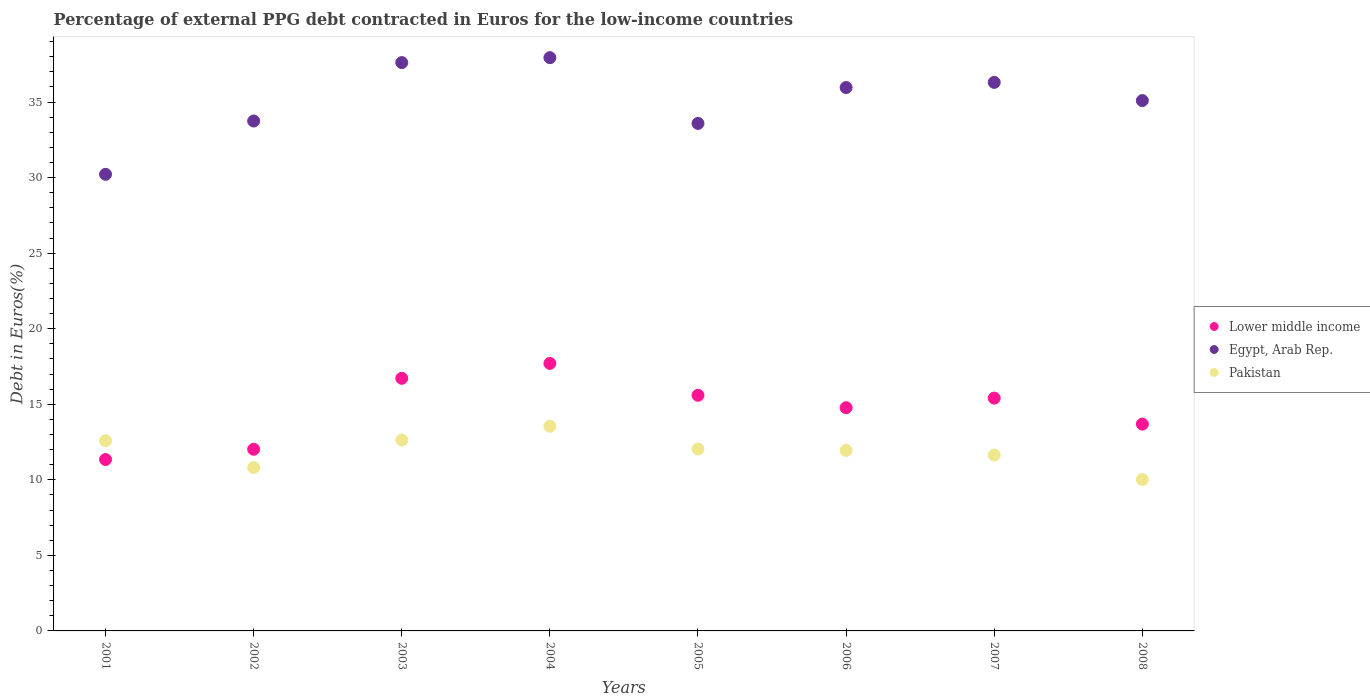How many different coloured dotlines are there?
Your answer should be compact. 3. Is the number of dotlines equal to the number of legend labels?
Provide a succinct answer. Yes. What is the percentage of external PPG debt contracted in Euros in Pakistan in 2005?
Provide a short and direct response. 12.04. Across all years, what is the maximum percentage of external PPG debt contracted in Euros in Lower middle income?
Keep it short and to the point. 17.71. Across all years, what is the minimum percentage of external PPG debt contracted in Euros in Lower middle income?
Your answer should be compact. 11.34. In which year was the percentage of external PPG debt contracted in Euros in Lower middle income maximum?
Make the answer very short. 2004. In which year was the percentage of external PPG debt contracted in Euros in Lower middle income minimum?
Your answer should be compact. 2001. What is the total percentage of external PPG debt contracted in Euros in Lower middle income in the graph?
Ensure brevity in your answer.  117.26. What is the difference between the percentage of external PPG debt contracted in Euros in Egypt, Arab Rep. in 2001 and that in 2005?
Offer a very short reply. -3.37. What is the difference between the percentage of external PPG debt contracted in Euros in Lower middle income in 2007 and the percentage of external PPG debt contracted in Euros in Egypt, Arab Rep. in 2008?
Provide a succinct answer. -19.69. What is the average percentage of external PPG debt contracted in Euros in Lower middle income per year?
Make the answer very short. 14.66. In the year 2005, what is the difference between the percentage of external PPG debt contracted in Euros in Lower middle income and percentage of external PPG debt contracted in Euros in Pakistan?
Your answer should be very brief. 3.55. What is the ratio of the percentage of external PPG debt contracted in Euros in Lower middle income in 2002 to that in 2003?
Your answer should be compact. 0.72. Is the difference between the percentage of external PPG debt contracted in Euros in Lower middle income in 2002 and 2008 greater than the difference between the percentage of external PPG debt contracted in Euros in Pakistan in 2002 and 2008?
Provide a succinct answer. No. What is the difference between the highest and the second highest percentage of external PPG debt contracted in Euros in Pakistan?
Provide a short and direct response. 0.91. What is the difference between the highest and the lowest percentage of external PPG debt contracted in Euros in Egypt, Arab Rep.?
Offer a very short reply. 7.72. In how many years, is the percentage of external PPG debt contracted in Euros in Pakistan greater than the average percentage of external PPG debt contracted in Euros in Pakistan taken over all years?
Keep it short and to the point. 5. Is the sum of the percentage of external PPG debt contracted in Euros in Lower middle income in 2001 and 2004 greater than the maximum percentage of external PPG debt contracted in Euros in Egypt, Arab Rep. across all years?
Give a very brief answer. No. Is it the case that in every year, the sum of the percentage of external PPG debt contracted in Euros in Lower middle income and percentage of external PPG debt contracted in Euros in Egypt, Arab Rep.  is greater than the percentage of external PPG debt contracted in Euros in Pakistan?
Keep it short and to the point. Yes. How many years are there in the graph?
Offer a very short reply. 8. Does the graph contain grids?
Your answer should be very brief. No. What is the title of the graph?
Your answer should be very brief. Percentage of external PPG debt contracted in Euros for the low-income countries. What is the label or title of the X-axis?
Provide a succinct answer. Years. What is the label or title of the Y-axis?
Your answer should be very brief. Debt in Euros(%). What is the Debt in Euros(%) of Lower middle income in 2001?
Your response must be concise. 11.34. What is the Debt in Euros(%) of Egypt, Arab Rep. in 2001?
Provide a short and direct response. 30.22. What is the Debt in Euros(%) in Pakistan in 2001?
Offer a terse response. 12.59. What is the Debt in Euros(%) in Lower middle income in 2002?
Give a very brief answer. 12.02. What is the Debt in Euros(%) in Egypt, Arab Rep. in 2002?
Provide a succinct answer. 33.75. What is the Debt in Euros(%) in Pakistan in 2002?
Provide a succinct answer. 10.81. What is the Debt in Euros(%) of Lower middle income in 2003?
Offer a very short reply. 16.72. What is the Debt in Euros(%) in Egypt, Arab Rep. in 2003?
Give a very brief answer. 37.61. What is the Debt in Euros(%) in Pakistan in 2003?
Make the answer very short. 12.63. What is the Debt in Euros(%) in Lower middle income in 2004?
Your answer should be very brief. 17.71. What is the Debt in Euros(%) in Egypt, Arab Rep. in 2004?
Provide a succinct answer. 37.94. What is the Debt in Euros(%) of Pakistan in 2004?
Make the answer very short. 13.54. What is the Debt in Euros(%) of Lower middle income in 2005?
Your answer should be compact. 15.6. What is the Debt in Euros(%) in Egypt, Arab Rep. in 2005?
Provide a succinct answer. 33.59. What is the Debt in Euros(%) in Pakistan in 2005?
Offer a terse response. 12.04. What is the Debt in Euros(%) in Lower middle income in 2006?
Offer a terse response. 14.77. What is the Debt in Euros(%) of Egypt, Arab Rep. in 2006?
Offer a very short reply. 35.96. What is the Debt in Euros(%) in Pakistan in 2006?
Provide a short and direct response. 11.95. What is the Debt in Euros(%) of Lower middle income in 2007?
Offer a very short reply. 15.41. What is the Debt in Euros(%) in Egypt, Arab Rep. in 2007?
Your answer should be very brief. 36.3. What is the Debt in Euros(%) of Pakistan in 2007?
Make the answer very short. 11.64. What is the Debt in Euros(%) in Lower middle income in 2008?
Give a very brief answer. 13.69. What is the Debt in Euros(%) in Egypt, Arab Rep. in 2008?
Make the answer very short. 35.1. What is the Debt in Euros(%) of Pakistan in 2008?
Provide a short and direct response. 10.02. Across all years, what is the maximum Debt in Euros(%) in Lower middle income?
Your answer should be compact. 17.71. Across all years, what is the maximum Debt in Euros(%) of Egypt, Arab Rep.?
Your response must be concise. 37.94. Across all years, what is the maximum Debt in Euros(%) of Pakistan?
Provide a succinct answer. 13.54. Across all years, what is the minimum Debt in Euros(%) of Lower middle income?
Ensure brevity in your answer.  11.34. Across all years, what is the minimum Debt in Euros(%) of Egypt, Arab Rep.?
Make the answer very short. 30.22. Across all years, what is the minimum Debt in Euros(%) of Pakistan?
Your response must be concise. 10.02. What is the total Debt in Euros(%) of Lower middle income in the graph?
Give a very brief answer. 117.26. What is the total Debt in Euros(%) in Egypt, Arab Rep. in the graph?
Provide a short and direct response. 280.47. What is the total Debt in Euros(%) of Pakistan in the graph?
Ensure brevity in your answer.  95.23. What is the difference between the Debt in Euros(%) in Lower middle income in 2001 and that in 2002?
Offer a very short reply. -0.68. What is the difference between the Debt in Euros(%) in Egypt, Arab Rep. in 2001 and that in 2002?
Offer a terse response. -3.53. What is the difference between the Debt in Euros(%) of Pakistan in 2001 and that in 2002?
Ensure brevity in your answer.  1.77. What is the difference between the Debt in Euros(%) of Lower middle income in 2001 and that in 2003?
Provide a short and direct response. -5.38. What is the difference between the Debt in Euros(%) in Egypt, Arab Rep. in 2001 and that in 2003?
Provide a short and direct response. -7.39. What is the difference between the Debt in Euros(%) of Pakistan in 2001 and that in 2003?
Keep it short and to the point. -0.05. What is the difference between the Debt in Euros(%) in Lower middle income in 2001 and that in 2004?
Keep it short and to the point. -6.36. What is the difference between the Debt in Euros(%) of Egypt, Arab Rep. in 2001 and that in 2004?
Provide a succinct answer. -7.72. What is the difference between the Debt in Euros(%) in Pakistan in 2001 and that in 2004?
Offer a terse response. -0.96. What is the difference between the Debt in Euros(%) of Lower middle income in 2001 and that in 2005?
Give a very brief answer. -4.25. What is the difference between the Debt in Euros(%) in Egypt, Arab Rep. in 2001 and that in 2005?
Offer a very short reply. -3.37. What is the difference between the Debt in Euros(%) of Pakistan in 2001 and that in 2005?
Your answer should be very brief. 0.54. What is the difference between the Debt in Euros(%) of Lower middle income in 2001 and that in 2006?
Offer a terse response. -3.43. What is the difference between the Debt in Euros(%) in Egypt, Arab Rep. in 2001 and that in 2006?
Make the answer very short. -5.74. What is the difference between the Debt in Euros(%) in Pakistan in 2001 and that in 2006?
Keep it short and to the point. 0.64. What is the difference between the Debt in Euros(%) of Lower middle income in 2001 and that in 2007?
Your answer should be very brief. -4.06. What is the difference between the Debt in Euros(%) in Egypt, Arab Rep. in 2001 and that in 2007?
Offer a very short reply. -6.08. What is the difference between the Debt in Euros(%) in Pakistan in 2001 and that in 2007?
Offer a very short reply. 0.95. What is the difference between the Debt in Euros(%) in Lower middle income in 2001 and that in 2008?
Your response must be concise. -2.34. What is the difference between the Debt in Euros(%) in Egypt, Arab Rep. in 2001 and that in 2008?
Give a very brief answer. -4.88. What is the difference between the Debt in Euros(%) of Pakistan in 2001 and that in 2008?
Make the answer very short. 2.57. What is the difference between the Debt in Euros(%) of Lower middle income in 2002 and that in 2003?
Provide a short and direct response. -4.7. What is the difference between the Debt in Euros(%) of Egypt, Arab Rep. in 2002 and that in 2003?
Provide a succinct answer. -3.87. What is the difference between the Debt in Euros(%) in Pakistan in 2002 and that in 2003?
Offer a very short reply. -1.82. What is the difference between the Debt in Euros(%) of Lower middle income in 2002 and that in 2004?
Your answer should be compact. -5.68. What is the difference between the Debt in Euros(%) in Egypt, Arab Rep. in 2002 and that in 2004?
Provide a succinct answer. -4.19. What is the difference between the Debt in Euros(%) in Pakistan in 2002 and that in 2004?
Offer a very short reply. -2.73. What is the difference between the Debt in Euros(%) of Lower middle income in 2002 and that in 2005?
Give a very brief answer. -3.57. What is the difference between the Debt in Euros(%) of Egypt, Arab Rep. in 2002 and that in 2005?
Ensure brevity in your answer.  0.16. What is the difference between the Debt in Euros(%) in Pakistan in 2002 and that in 2005?
Give a very brief answer. -1.23. What is the difference between the Debt in Euros(%) of Lower middle income in 2002 and that in 2006?
Your response must be concise. -2.75. What is the difference between the Debt in Euros(%) in Egypt, Arab Rep. in 2002 and that in 2006?
Keep it short and to the point. -2.22. What is the difference between the Debt in Euros(%) in Pakistan in 2002 and that in 2006?
Your answer should be compact. -1.14. What is the difference between the Debt in Euros(%) of Lower middle income in 2002 and that in 2007?
Provide a short and direct response. -3.39. What is the difference between the Debt in Euros(%) in Egypt, Arab Rep. in 2002 and that in 2007?
Give a very brief answer. -2.56. What is the difference between the Debt in Euros(%) of Pakistan in 2002 and that in 2007?
Ensure brevity in your answer.  -0.83. What is the difference between the Debt in Euros(%) in Lower middle income in 2002 and that in 2008?
Your answer should be very brief. -1.66. What is the difference between the Debt in Euros(%) of Egypt, Arab Rep. in 2002 and that in 2008?
Provide a short and direct response. -1.35. What is the difference between the Debt in Euros(%) in Pakistan in 2002 and that in 2008?
Give a very brief answer. 0.79. What is the difference between the Debt in Euros(%) of Lower middle income in 2003 and that in 2004?
Give a very brief answer. -0.99. What is the difference between the Debt in Euros(%) in Egypt, Arab Rep. in 2003 and that in 2004?
Make the answer very short. -0.33. What is the difference between the Debt in Euros(%) of Pakistan in 2003 and that in 2004?
Your answer should be compact. -0.91. What is the difference between the Debt in Euros(%) in Lower middle income in 2003 and that in 2005?
Your answer should be very brief. 1.12. What is the difference between the Debt in Euros(%) of Egypt, Arab Rep. in 2003 and that in 2005?
Ensure brevity in your answer.  4.02. What is the difference between the Debt in Euros(%) in Pakistan in 2003 and that in 2005?
Ensure brevity in your answer.  0.59. What is the difference between the Debt in Euros(%) in Lower middle income in 2003 and that in 2006?
Provide a succinct answer. 1.95. What is the difference between the Debt in Euros(%) in Egypt, Arab Rep. in 2003 and that in 2006?
Offer a terse response. 1.65. What is the difference between the Debt in Euros(%) of Pakistan in 2003 and that in 2006?
Make the answer very short. 0.69. What is the difference between the Debt in Euros(%) in Lower middle income in 2003 and that in 2007?
Your answer should be compact. 1.31. What is the difference between the Debt in Euros(%) in Egypt, Arab Rep. in 2003 and that in 2007?
Ensure brevity in your answer.  1.31. What is the difference between the Debt in Euros(%) of Pakistan in 2003 and that in 2007?
Provide a short and direct response. 1. What is the difference between the Debt in Euros(%) of Lower middle income in 2003 and that in 2008?
Provide a short and direct response. 3.03. What is the difference between the Debt in Euros(%) of Egypt, Arab Rep. in 2003 and that in 2008?
Keep it short and to the point. 2.51. What is the difference between the Debt in Euros(%) in Pakistan in 2003 and that in 2008?
Your answer should be compact. 2.61. What is the difference between the Debt in Euros(%) in Lower middle income in 2004 and that in 2005?
Your response must be concise. 2.11. What is the difference between the Debt in Euros(%) in Egypt, Arab Rep. in 2004 and that in 2005?
Provide a short and direct response. 4.35. What is the difference between the Debt in Euros(%) in Pakistan in 2004 and that in 2005?
Your answer should be compact. 1.5. What is the difference between the Debt in Euros(%) in Lower middle income in 2004 and that in 2006?
Offer a terse response. 2.93. What is the difference between the Debt in Euros(%) in Egypt, Arab Rep. in 2004 and that in 2006?
Keep it short and to the point. 1.98. What is the difference between the Debt in Euros(%) in Pakistan in 2004 and that in 2006?
Your answer should be very brief. 1.6. What is the difference between the Debt in Euros(%) of Lower middle income in 2004 and that in 2007?
Offer a terse response. 2.3. What is the difference between the Debt in Euros(%) of Egypt, Arab Rep. in 2004 and that in 2007?
Ensure brevity in your answer.  1.64. What is the difference between the Debt in Euros(%) in Pakistan in 2004 and that in 2007?
Give a very brief answer. 1.91. What is the difference between the Debt in Euros(%) of Lower middle income in 2004 and that in 2008?
Your response must be concise. 4.02. What is the difference between the Debt in Euros(%) in Egypt, Arab Rep. in 2004 and that in 2008?
Keep it short and to the point. 2.84. What is the difference between the Debt in Euros(%) of Pakistan in 2004 and that in 2008?
Ensure brevity in your answer.  3.52. What is the difference between the Debt in Euros(%) of Lower middle income in 2005 and that in 2006?
Your answer should be compact. 0.82. What is the difference between the Debt in Euros(%) of Egypt, Arab Rep. in 2005 and that in 2006?
Offer a terse response. -2.37. What is the difference between the Debt in Euros(%) in Pakistan in 2005 and that in 2006?
Ensure brevity in your answer.  0.1. What is the difference between the Debt in Euros(%) in Lower middle income in 2005 and that in 2007?
Make the answer very short. 0.19. What is the difference between the Debt in Euros(%) of Egypt, Arab Rep. in 2005 and that in 2007?
Your response must be concise. -2.71. What is the difference between the Debt in Euros(%) in Pakistan in 2005 and that in 2007?
Ensure brevity in your answer.  0.41. What is the difference between the Debt in Euros(%) in Lower middle income in 2005 and that in 2008?
Provide a short and direct response. 1.91. What is the difference between the Debt in Euros(%) in Egypt, Arab Rep. in 2005 and that in 2008?
Provide a succinct answer. -1.51. What is the difference between the Debt in Euros(%) of Pakistan in 2005 and that in 2008?
Your response must be concise. 2.02. What is the difference between the Debt in Euros(%) of Lower middle income in 2006 and that in 2007?
Your response must be concise. -0.64. What is the difference between the Debt in Euros(%) in Egypt, Arab Rep. in 2006 and that in 2007?
Offer a very short reply. -0.34. What is the difference between the Debt in Euros(%) in Pakistan in 2006 and that in 2007?
Make the answer very short. 0.31. What is the difference between the Debt in Euros(%) in Lower middle income in 2006 and that in 2008?
Give a very brief answer. 1.09. What is the difference between the Debt in Euros(%) of Egypt, Arab Rep. in 2006 and that in 2008?
Your answer should be very brief. 0.86. What is the difference between the Debt in Euros(%) in Pakistan in 2006 and that in 2008?
Provide a short and direct response. 1.93. What is the difference between the Debt in Euros(%) in Lower middle income in 2007 and that in 2008?
Your answer should be very brief. 1.72. What is the difference between the Debt in Euros(%) in Egypt, Arab Rep. in 2007 and that in 2008?
Keep it short and to the point. 1.2. What is the difference between the Debt in Euros(%) of Pakistan in 2007 and that in 2008?
Your answer should be very brief. 1.62. What is the difference between the Debt in Euros(%) of Lower middle income in 2001 and the Debt in Euros(%) of Egypt, Arab Rep. in 2002?
Keep it short and to the point. -22.4. What is the difference between the Debt in Euros(%) of Lower middle income in 2001 and the Debt in Euros(%) of Pakistan in 2002?
Make the answer very short. 0.53. What is the difference between the Debt in Euros(%) in Egypt, Arab Rep. in 2001 and the Debt in Euros(%) in Pakistan in 2002?
Offer a terse response. 19.41. What is the difference between the Debt in Euros(%) in Lower middle income in 2001 and the Debt in Euros(%) in Egypt, Arab Rep. in 2003?
Ensure brevity in your answer.  -26.27. What is the difference between the Debt in Euros(%) of Lower middle income in 2001 and the Debt in Euros(%) of Pakistan in 2003?
Give a very brief answer. -1.29. What is the difference between the Debt in Euros(%) in Egypt, Arab Rep. in 2001 and the Debt in Euros(%) in Pakistan in 2003?
Your response must be concise. 17.59. What is the difference between the Debt in Euros(%) of Lower middle income in 2001 and the Debt in Euros(%) of Egypt, Arab Rep. in 2004?
Ensure brevity in your answer.  -26.6. What is the difference between the Debt in Euros(%) of Lower middle income in 2001 and the Debt in Euros(%) of Pakistan in 2004?
Give a very brief answer. -2.2. What is the difference between the Debt in Euros(%) of Egypt, Arab Rep. in 2001 and the Debt in Euros(%) of Pakistan in 2004?
Make the answer very short. 16.68. What is the difference between the Debt in Euros(%) of Lower middle income in 2001 and the Debt in Euros(%) of Egypt, Arab Rep. in 2005?
Your answer should be compact. -22.25. What is the difference between the Debt in Euros(%) of Lower middle income in 2001 and the Debt in Euros(%) of Pakistan in 2005?
Provide a succinct answer. -0.7. What is the difference between the Debt in Euros(%) of Egypt, Arab Rep. in 2001 and the Debt in Euros(%) of Pakistan in 2005?
Keep it short and to the point. 18.18. What is the difference between the Debt in Euros(%) in Lower middle income in 2001 and the Debt in Euros(%) in Egypt, Arab Rep. in 2006?
Keep it short and to the point. -24.62. What is the difference between the Debt in Euros(%) of Lower middle income in 2001 and the Debt in Euros(%) of Pakistan in 2006?
Your answer should be compact. -0.6. What is the difference between the Debt in Euros(%) of Egypt, Arab Rep. in 2001 and the Debt in Euros(%) of Pakistan in 2006?
Make the answer very short. 18.27. What is the difference between the Debt in Euros(%) of Lower middle income in 2001 and the Debt in Euros(%) of Egypt, Arab Rep. in 2007?
Provide a short and direct response. -24.96. What is the difference between the Debt in Euros(%) in Lower middle income in 2001 and the Debt in Euros(%) in Pakistan in 2007?
Make the answer very short. -0.3. What is the difference between the Debt in Euros(%) of Egypt, Arab Rep. in 2001 and the Debt in Euros(%) of Pakistan in 2007?
Provide a short and direct response. 18.58. What is the difference between the Debt in Euros(%) of Lower middle income in 2001 and the Debt in Euros(%) of Egypt, Arab Rep. in 2008?
Provide a succinct answer. -23.76. What is the difference between the Debt in Euros(%) in Lower middle income in 2001 and the Debt in Euros(%) in Pakistan in 2008?
Offer a terse response. 1.32. What is the difference between the Debt in Euros(%) of Egypt, Arab Rep. in 2001 and the Debt in Euros(%) of Pakistan in 2008?
Give a very brief answer. 20.2. What is the difference between the Debt in Euros(%) of Lower middle income in 2002 and the Debt in Euros(%) of Egypt, Arab Rep. in 2003?
Offer a terse response. -25.59. What is the difference between the Debt in Euros(%) of Lower middle income in 2002 and the Debt in Euros(%) of Pakistan in 2003?
Provide a succinct answer. -0.61. What is the difference between the Debt in Euros(%) in Egypt, Arab Rep. in 2002 and the Debt in Euros(%) in Pakistan in 2003?
Offer a very short reply. 21.11. What is the difference between the Debt in Euros(%) of Lower middle income in 2002 and the Debt in Euros(%) of Egypt, Arab Rep. in 2004?
Give a very brief answer. -25.92. What is the difference between the Debt in Euros(%) in Lower middle income in 2002 and the Debt in Euros(%) in Pakistan in 2004?
Offer a terse response. -1.52. What is the difference between the Debt in Euros(%) in Egypt, Arab Rep. in 2002 and the Debt in Euros(%) in Pakistan in 2004?
Your answer should be compact. 20.2. What is the difference between the Debt in Euros(%) in Lower middle income in 2002 and the Debt in Euros(%) in Egypt, Arab Rep. in 2005?
Ensure brevity in your answer.  -21.57. What is the difference between the Debt in Euros(%) of Lower middle income in 2002 and the Debt in Euros(%) of Pakistan in 2005?
Offer a terse response. -0.02. What is the difference between the Debt in Euros(%) in Egypt, Arab Rep. in 2002 and the Debt in Euros(%) in Pakistan in 2005?
Offer a very short reply. 21.7. What is the difference between the Debt in Euros(%) in Lower middle income in 2002 and the Debt in Euros(%) in Egypt, Arab Rep. in 2006?
Ensure brevity in your answer.  -23.94. What is the difference between the Debt in Euros(%) in Lower middle income in 2002 and the Debt in Euros(%) in Pakistan in 2006?
Keep it short and to the point. 0.08. What is the difference between the Debt in Euros(%) in Egypt, Arab Rep. in 2002 and the Debt in Euros(%) in Pakistan in 2006?
Offer a very short reply. 21.8. What is the difference between the Debt in Euros(%) in Lower middle income in 2002 and the Debt in Euros(%) in Egypt, Arab Rep. in 2007?
Keep it short and to the point. -24.28. What is the difference between the Debt in Euros(%) of Lower middle income in 2002 and the Debt in Euros(%) of Pakistan in 2007?
Offer a very short reply. 0.38. What is the difference between the Debt in Euros(%) of Egypt, Arab Rep. in 2002 and the Debt in Euros(%) of Pakistan in 2007?
Keep it short and to the point. 22.11. What is the difference between the Debt in Euros(%) in Lower middle income in 2002 and the Debt in Euros(%) in Egypt, Arab Rep. in 2008?
Make the answer very short. -23.08. What is the difference between the Debt in Euros(%) in Lower middle income in 2002 and the Debt in Euros(%) in Pakistan in 2008?
Ensure brevity in your answer.  2. What is the difference between the Debt in Euros(%) of Egypt, Arab Rep. in 2002 and the Debt in Euros(%) of Pakistan in 2008?
Offer a terse response. 23.73. What is the difference between the Debt in Euros(%) in Lower middle income in 2003 and the Debt in Euros(%) in Egypt, Arab Rep. in 2004?
Your response must be concise. -21.22. What is the difference between the Debt in Euros(%) in Lower middle income in 2003 and the Debt in Euros(%) in Pakistan in 2004?
Provide a succinct answer. 3.17. What is the difference between the Debt in Euros(%) in Egypt, Arab Rep. in 2003 and the Debt in Euros(%) in Pakistan in 2004?
Give a very brief answer. 24.07. What is the difference between the Debt in Euros(%) of Lower middle income in 2003 and the Debt in Euros(%) of Egypt, Arab Rep. in 2005?
Your answer should be compact. -16.87. What is the difference between the Debt in Euros(%) in Lower middle income in 2003 and the Debt in Euros(%) in Pakistan in 2005?
Provide a succinct answer. 4.68. What is the difference between the Debt in Euros(%) of Egypt, Arab Rep. in 2003 and the Debt in Euros(%) of Pakistan in 2005?
Make the answer very short. 25.57. What is the difference between the Debt in Euros(%) of Lower middle income in 2003 and the Debt in Euros(%) of Egypt, Arab Rep. in 2006?
Ensure brevity in your answer.  -19.24. What is the difference between the Debt in Euros(%) in Lower middle income in 2003 and the Debt in Euros(%) in Pakistan in 2006?
Your response must be concise. 4.77. What is the difference between the Debt in Euros(%) of Egypt, Arab Rep. in 2003 and the Debt in Euros(%) of Pakistan in 2006?
Give a very brief answer. 25.67. What is the difference between the Debt in Euros(%) in Lower middle income in 2003 and the Debt in Euros(%) in Egypt, Arab Rep. in 2007?
Keep it short and to the point. -19.58. What is the difference between the Debt in Euros(%) in Lower middle income in 2003 and the Debt in Euros(%) in Pakistan in 2007?
Your answer should be very brief. 5.08. What is the difference between the Debt in Euros(%) of Egypt, Arab Rep. in 2003 and the Debt in Euros(%) of Pakistan in 2007?
Offer a very short reply. 25.97. What is the difference between the Debt in Euros(%) in Lower middle income in 2003 and the Debt in Euros(%) in Egypt, Arab Rep. in 2008?
Offer a terse response. -18.38. What is the difference between the Debt in Euros(%) of Lower middle income in 2003 and the Debt in Euros(%) of Pakistan in 2008?
Give a very brief answer. 6.7. What is the difference between the Debt in Euros(%) in Egypt, Arab Rep. in 2003 and the Debt in Euros(%) in Pakistan in 2008?
Your answer should be very brief. 27.59. What is the difference between the Debt in Euros(%) in Lower middle income in 2004 and the Debt in Euros(%) in Egypt, Arab Rep. in 2005?
Offer a very short reply. -15.88. What is the difference between the Debt in Euros(%) in Lower middle income in 2004 and the Debt in Euros(%) in Pakistan in 2005?
Your answer should be compact. 5.66. What is the difference between the Debt in Euros(%) in Egypt, Arab Rep. in 2004 and the Debt in Euros(%) in Pakistan in 2005?
Offer a very short reply. 25.9. What is the difference between the Debt in Euros(%) of Lower middle income in 2004 and the Debt in Euros(%) of Egypt, Arab Rep. in 2006?
Your answer should be very brief. -18.26. What is the difference between the Debt in Euros(%) in Lower middle income in 2004 and the Debt in Euros(%) in Pakistan in 2006?
Keep it short and to the point. 5.76. What is the difference between the Debt in Euros(%) of Egypt, Arab Rep. in 2004 and the Debt in Euros(%) of Pakistan in 2006?
Offer a very short reply. 25.99. What is the difference between the Debt in Euros(%) of Lower middle income in 2004 and the Debt in Euros(%) of Egypt, Arab Rep. in 2007?
Your answer should be very brief. -18.6. What is the difference between the Debt in Euros(%) in Lower middle income in 2004 and the Debt in Euros(%) in Pakistan in 2007?
Offer a terse response. 6.07. What is the difference between the Debt in Euros(%) in Egypt, Arab Rep. in 2004 and the Debt in Euros(%) in Pakistan in 2007?
Make the answer very short. 26.3. What is the difference between the Debt in Euros(%) of Lower middle income in 2004 and the Debt in Euros(%) of Egypt, Arab Rep. in 2008?
Give a very brief answer. -17.39. What is the difference between the Debt in Euros(%) in Lower middle income in 2004 and the Debt in Euros(%) in Pakistan in 2008?
Give a very brief answer. 7.69. What is the difference between the Debt in Euros(%) in Egypt, Arab Rep. in 2004 and the Debt in Euros(%) in Pakistan in 2008?
Give a very brief answer. 27.92. What is the difference between the Debt in Euros(%) in Lower middle income in 2005 and the Debt in Euros(%) in Egypt, Arab Rep. in 2006?
Keep it short and to the point. -20.37. What is the difference between the Debt in Euros(%) in Lower middle income in 2005 and the Debt in Euros(%) in Pakistan in 2006?
Keep it short and to the point. 3.65. What is the difference between the Debt in Euros(%) in Egypt, Arab Rep. in 2005 and the Debt in Euros(%) in Pakistan in 2006?
Offer a very short reply. 21.64. What is the difference between the Debt in Euros(%) in Lower middle income in 2005 and the Debt in Euros(%) in Egypt, Arab Rep. in 2007?
Your answer should be very brief. -20.71. What is the difference between the Debt in Euros(%) of Lower middle income in 2005 and the Debt in Euros(%) of Pakistan in 2007?
Your response must be concise. 3.96. What is the difference between the Debt in Euros(%) in Egypt, Arab Rep. in 2005 and the Debt in Euros(%) in Pakistan in 2007?
Make the answer very short. 21.95. What is the difference between the Debt in Euros(%) of Lower middle income in 2005 and the Debt in Euros(%) of Egypt, Arab Rep. in 2008?
Provide a short and direct response. -19.5. What is the difference between the Debt in Euros(%) in Lower middle income in 2005 and the Debt in Euros(%) in Pakistan in 2008?
Offer a terse response. 5.58. What is the difference between the Debt in Euros(%) of Egypt, Arab Rep. in 2005 and the Debt in Euros(%) of Pakistan in 2008?
Provide a short and direct response. 23.57. What is the difference between the Debt in Euros(%) in Lower middle income in 2006 and the Debt in Euros(%) in Egypt, Arab Rep. in 2007?
Provide a short and direct response. -21.53. What is the difference between the Debt in Euros(%) of Lower middle income in 2006 and the Debt in Euros(%) of Pakistan in 2007?
Provide a short and direct response. 3.13. What is the difference between the Debt in Euros(%) in Egypt, Arab Rep. in 2006 and the Debt in Euros(%) in Pakistan in 2007?
Your answer should be very brief. 24.32. What is the difference between the Debt in Euros(%) of Lower middle income in 2006 and the Debt in Euros(%) of Egypt, Arab Rep. in 2008?
Keep it short and to the point. -20.33. What is the difference between the Debt in Euros(%) in Lower middle income in 2006 and the Debt in Euros(%) in Pakistan in 2008?
Your answer should be compact. 4.75. What is the difference between the Debt in Euros(%) in Egypt, Arab Rep. in 2006 and the Debt in Euros(%) in Pakistan in 2008?
Your response must be concise. 25.94. What is the difference between the Debt in Euros(%) in Lower middle income in 2007 and the Debt in Euros(%) in Egypt, Arab Rep. in 2008?
Provide a short and direct response. -19.69. What is the difference between the Debt in Euros(%) in Lower middle income in 2007 and the Debt in Euros(%) in Pakistan in 2008?
Provide a short and direct response. 5.39. What is the difference between the Debt in Euros(%) in Egypt, Arab Rep. in 2007 and the Debt in Euros(%) in Pakistan in 2008?
Provide a succinct answer. 26.28. What is the average Debt in Euros(%) of Lower middle income per year?
Offer a very short reply. 14.66. What is the average Debt in Euros(%) of Egypt, Arab Rep. per year?
Offer a very short reply. 35.06. What is the average Debt in Euros(%) of Pakistan per year?
Offer a very short reply. 11.9. In the year 2001, what is the difference between the Debt in Euros(%) of Lower middle income and Debt in Euros(%) of Egypt, Arab Rep.?
Make the answer very short. -18.88. In the year 2001, what is the difference between the Debt in Euros(%) of Lower middle income and Debt in Euros(%) of Pakistan?
Offer a terse response. -1.24. In the year 2001, what is the difference between the Debt in Euros(%) of Egypt, Arab Rep. and Debt in Euros(%) of Pakistan?
Give a very brief answer. 17.63. In the year 2002, what is the difference between the Debt in Euros(%) in Lower middle income and Debt in Euros(%) in Egypt, Arab Rep.?
Provide a succinct answer. -21.72. In the year 2002, what is the difference between the Debt in Euros(%) in Lower middle income and Debt in Euros(%) in Pakistan?
Your answer should be compact. 1.21. In the year 2002, what is the difference between the Debt in Euros(%) in Egypt, Arab Rep. and Debt in Euros(%) in Pakistan?
Offer a terse response. 22.93. In the year 2003, what is the difference between the Debt in Euros(%) in Lower middle income and Debt in Euros(%) in Egypt, Arab Rep.?
Your answer should be very brief. -20.89. In the year 2003, what is the difference between the Debt in Euros(%) in Lower middle income and Debt in Euros(%) in Pakistan?
Offer a very short reply. 4.09. In the year 2003, what is the difference between the Debt in Euros(%) in Egypt, Arab Rep. and Debt in Euros(%) in Pakistan?
Ensure brevity in your answer.  24.98. In the year 2004, what is the difference between the Debt in Euros(%) of Lower middle income and Debt in Euros(%) of Egypt, Arab Rep.?
Your answer should be very brief. -20.23. In the year 2004, what is the difference between the Debt in Euros(%) of Lower middle income and Debt in Euros(%) of Pakistan?
Keep it short and to the point. 4.16. In the year 2004, what is the difference between the Debt in Euros(%) of Egypt, Arab Rep. and Debt in Euros(%) of Pakistan?
Ensure brevity in your answer.  24.4. In the year 2005, what is the difference between the Debt in Euros(%) in Lower middle income and Debt in Euros(%) in Egypt, Arab Rep.?
Give a very brief answer. -17.99. In the year 2005, what is the difference between the Debt in Euros(%) of Lower middle income and Debt in Euros(%) of Pakistan?
Your answer should be compact. 3.55. In the year 2005, what is the difference between the Debt in Euros(%) of Egypt, Arab Rep. and Debt in Euros(%) of Pakistan?
Keep it short and to the point. 21.55. In the year 2006, what is the difference between the Debt in Euros(%) of Lower middle income and Debt in Euros(%) of Egypt, Arab Rep.?
Offer a very short reply. -21.19. In the year 2006, what is the difference between the Debt in Euros(%) in Lower middle income and Debt in Euros(%) in Pakistan?
Offer a terse response. 2.83. In the year 2006, what is the difference between the Debt in Euros(%) in Egypt, Arab Rep. and Debt in Euros(%) in Pakistan?
Ensure brevity in your answer.  24.02. In the year 2007, what is the difference between the Debt in Euros(%) of Lower middle income and Debt in Euros(%) of Egypt, Arab Rep.?
Ensure brevity in your answer.  -20.89. In the year 2007, what is the difference between the Debt in Euros(%) in Lower middle income and Debt in Euros(%) in Pakistan?
Offer a terse response. 3.77. In the year 2007, what is the difference between the Debt in Euros(%) of Egypt, Arab Rep. and Debt in Euros(%) of Pakistan?
Provide a short and direct response. 24.66. In the year 2008, what is the difference between the Debt in Euros(%) in Lower middle income and Debt in Euros(%) in Egypt, Arab Rep.?
Give a very brief answer. -21.41. In the year 2008, what is the difference between the Debt in Euros(%) of Lower middle income and Debt in Euros(%) of Pakistan?
Your answer should be compact. 3.67. In the year 2008, what is the difference between the Debt in Euros(%) of Egypt, Arab Rep. and Debt in Euros(%) of Pakistan?
Provide a short and direct response. 25.08. What is the ratio of the Debt in Euros(%) of Lower middle income in 2001 to that in 2002?
Offer a terse response. 0.94. What is the ratio of the Debt in Euros(%) of Egypt, Arab Rep. in 2001 to that in 2002?
Provide a succinct answer. 0.9. What is the ratio of the Debt in Euros(%) of Pakistan in 2001 to that in 2002?
Your answer should be compact. 1.16. What is the ratio of the Debt in Euros(%) of Lower middle income in 2001 to that in 2003?
Offer a very short reply. 0.68. What is the ratio of the Debt in Euros(%) of Egypt, Arab Rep. in 2001 to that in 2003?
Keep it short and to the point. 0.8. What is the ratio of the Debt in Euros(%) in Pakistan in 2001 to that in 2003?
Provide a short and direct response. 1. What is the ratio of the Debt in Euros(%) of Lower middle income in 2001 to that in 2004?
Provide a succinct answer. 0.64. What is the ratio of the Debt in Euros(%) of Egypt, Arab Rep. in 2001 to that in 2004?
Your answer should be compact. 0.8. What is the ratio of the Debt in Euros(%) in Pakistan in 2001 to that in 2004?
Provide a short and direct response. 0.93. What is the ratio of the Debt in Euros(%) of Lower middle income in 2001 to that in 2005?
Keep it short and to the point. 0.73. What is the ratio of the Debt in Euros(%) of Egypt, Arab Rep. in 2001 to that in 2005?
Offer a very short reply. 0.9. What is the ratio of the Debt in Euros(%) in Pakistan in 2001 to that in 2005?
Your answer should be very brief. 1.04. What is the ratio of the Debt in Euros(%) in Lower middle income in 2001 to that in 2006?
Your answer should be compact. 0.77. What is the ratio of the Debt in Euros(%) in Egypt, Arab Rep. in 2001 to that in 2006?
Keep it short and to the point. 0.84. What is the ratio of the Debt in Euros(%) in Pakistan in 2001 to that in 2006?
Your answer should be very brief. 1.05. What is the ratio of the Debt in Euros(%) of Lower middle income in 2001 to that in 2007?
Your answer should be very brief. 0.74. What is the ratio of the Debt in Euros(%) in Egypt, Arab Rep. in 2001 to that in 2007?
Your response must be concise. 0.83. What is the ratio of the Debt in Euros(%) in Pakistan in 2001 to that in 2007?
Make the answer very short. 1.08. What is the ratio of the Debt in Euros(%) in Lower middle income in 2001 to that in 2008?
Provide a succinct answer. 0.83. What is the ratio of the Debt in Euros(%) in Egypt, Arab Rep. in 2001 to that in 2008?
Give a very brief answer. 0.86. What is the ratio of the Debt in Euros(%) of Pakistan in 2001 to that in 2008?
Your response must be concise. 1.26. What is the ratio of the Debt in Euros(%) of Lower middle income in 2002 to that in 2003?
Keep it short and to the point. 0.72. What is the ratio of the Debt in Euros(%) in Egypt, Arab Rep. in 2002 to that in 2003?
Offer a very short reply. 0.9. What is the ratio of the Debt in Euros(%) in Pakistan in 2002 to that in 2003?
Ensure brevity in your answer.  0.86. What is the ratio of the Debt in Euros(%) in Lower middle income in 2002 to that in 2004?
Ensure brevity in your answer.  0.68. What is the ratio of the Debt in Euros(%) in Egypt, Arab Rep. in 2002 to that in 2004?
Your answer should be compact. 0.89. What is the ratio of the Debt in Euros(%) of Pakistan in 2002 to that in 2004?
Provide a succinct answer. 0.8. What is the ratio of the Debt in Euros(%) in Lower middle income in 2002 to that in 2005?
Provide a short and direct response. 0.77. What is the ratio of the Debt in Euros(%) of Pakistan in 2002 to that in 2005?
Make the answer very short. 0.9. What is the ratio of the Debt in Euros(%) in Lower middle income in 2002 to that in 2006?
Your answer should be very brief. 0.81. What is the ratio of the Debt in Euros(%) of Egypt, Arab Rep. in 2002 to that in 2006?
Provide a short and direct response. 0.94. What is the ratio of the Debt in Euros(%) in Pakistan in 2002 to that in 2006?
Make the answer very short. 0.91. What is the ratio of the Debt in Euros(%) in Lower middle income in 2002 to that in 2007?
Offer a terse response. 0.78. What is the ratio of the Debt in Euros(%) in Egypt, Arab Rep. in 2002 to that in 2007?
Offer a very short reply. 0.93. What is the ratio of the Debt in Euros(%) of Pakistan in 2002 to that in 2007?
Offer a very short reply. 0.93. What is the ratio of the Debt in Euros(%) in Lower middle income in 2002 to that in 2008?
Offer a very short reply. 0.88. What is the ratio of the Debt in Euros(%) in Egypt, Arab Rep. in 2002 to that in 2008?
Provide a succinct answer. 0.96. What is the ratio of the Debt in Euros(%) in Pakistan in 2002 to that in 2008?
Provide a short and direct response. 1.08. What is the ratio of the Debt in Euros(%) of Lower middle income in 2003 to that in 2004?
Give a very brief answer. 0.94. What is the ratio of the Debt in Euros(%) of Egypt, Arab Rep. in 2003 to that in 2004?
Offer a very short reply. 0.99. What is the ratio of the Debt in Euros(%) in Pakistan in 2003 to that in 2004?
Give a very brief answer. 0.93. What is the ratio of the Debt in Euros(%) in Lower middle income in 2003 to that in 2005?
Offer a very short reply. 1.07. What is the ratio of the Debt in Euros(%) in Egypt, Arab Rep. in 2003 to that in 2005?
Provide a short and direct response. 1.12. What is the ratio of the Debt in Euros(%) in Pakistan in 2003 to that in 2005?
Keep it short and to the point. 1.05. What is the ratio of the Debt in Euros(%) in Lower middle income in 2003 to that in 2006?
Your response must be concise. 1.13. What is the ratio of the Debt in Euros(%) of Egypt, Arab Rep. in 2003 to that in 2006?
Your answer should be compact. 1.05. What is the ratio of the Debt in Euros(%) in Pakistan in 2003 to that in 2006?
Provide a short and direct response. 1.06. What is the ratio of the Debt in Euros(%) in Lower middle income in 2003 to that in 2007?
Ensure brevity in your answer.  1.09. What is the ratio of the Debt in Euros(%) in Egypt, Arab Rep. in 2003 to that in 2007?
Offer a terse response. 1.04. What is the ratio of the Debt in Euros(%) of Pakistan in 2003 to that in 2007?
Offer a very short reply. 1.09. What is the ratio of the Debt in Euros(%) of Lower middle income in 2003 to that in 2008?
Your answer should be compact. 1.22. What is the ratio of the Debt in Euros(%) in Egypt, Arab Rep. in 2003 to that in 2008?
Make the answer very short. 1.07. What is the ratio of the Debt in Euros(%) of Pakistan in 2003 to that in 2008?
Your answer should be very brief. 1.26. What is the ratio of the Debt in Euros(%) of Lower middle income in 2004 to that in 2005?
Make the answer very short. 1.14. What is the ratio of the Debt in Euros(%) in Egypt, Arab Rep. in 2004 to that in 2005?
Make the answer very short. 1.13. What is the ratio of the Debt in Euros(%) of Pakistan in 2004 to that in 2005?
Keep it short and to the point. 1.12. What is the ratio of the Debt in Euros(%) of Lower middle income in 2004 to that in 2006?
Your answer should be compact. 1.2. What is the ratio of the Debt in Euros(%) in Egypt, Arab Rep. in 2004 to that in 2006?
Your answer should be very brief. 1.05. What is the ratio of the Debt in Euros(%) of Pakistan in 2004 to that in 2006?
Ensure brevity in your answer.  1.13. What is the ratio of the Debt in Euros(%) of Lower middle income in 2004 to that in 2007?
Offer a terse response. 1.15. What is the ratio of the Debt in Euros(%) in Egypt, Arab Rep. in 2004 to that in 2007?
Make the answer very short. 1.05. What is the ratio of the Debt in Euros(%) of Pakistan in 2004 to that in 2007?
Keep it short and to the point. 1.16. What is the ratio of the Debt in Euros(%) in Lower middle income in 2004 to that in 2008?
Provide a succinct answer. 1.29. What is the ratio of the Debt in Euros(%) in Egypt, Arab Rep. in 2004 to that in 2008?
Offer a very short reply. 1.08. What is the ratio of the Debt in Euros(%) of Pakistan in 2004 to that in 2008?
Offer a very short reply. 1.35. What is the ratio of the Debt in Euros(%) in Lower middle income in 2005 to that in 2006?
Offer a terse response. 1.06. What is the ratio of the Debt in Euros(%) in Egypt, Arab Rep. in 2005 to that in 2006?
Provide a short and direct response. 0.93. What is the ratio of the Debt in Euros(%) of Pakistan in 2005 to that in 2006?
Your answer should be compact. 1.01. What is the ratio of the Debt in Euros(%) in Lower middle income in 2005 to that in 2007?
Your answer should be very brief. 1.01. What is the ratio of the Debt in Euros(%) of Egypt, Arab Rep. in 2005 to that in 2007?
Give a very brief answer. 0.93. What is the ratio of the Debt in Euros(%) in Pakistan in 2005 to that in 2007?
Keep it short and to the point. 1.03. What is the ratio of the Debt in Euros(%) of Lower middle income in 2005 to that in 2008?
Your answer should be very brief. 1.14. What is the ratio of the Debt in Euros(%) in Pakistan in 2005 to that in 2008?
Your answer should be very brief. 1.2. What is the ratio of the Debt in Euros(%) of Lower middle income in 2006 to that in 2007?
Provide a short and direct response. 0.96. What is the ratio of the Debt in Euros(%) of Egypt, Arab Rep. in 2006 to that in 2007?
Provide a short and direct response. 0.99. What is the ratio of the Debt in Euros(%) of Pakistan in 2006 to that in 2007?
Your answer should be compact. 1.03. What is the ratio of the Debt in Euros(%) in Lower middle income in 2006 to that in 2008?
Your answer should be very brief. 1.08. What is the ratio of the Debt in Euros(%) of Egypt, Arab Rep. in 2006 to that in 2008?
Your response must be concise. 1.02. What is the ratio of the Debt in Euros(%) in Pakistan in 2006 to that in 2008?
Provide a short and direct response. 1.19. What is the ratio of the Debt in Euros(%) of Lower middle income in 2007 to that in 2008?
Provide a succinct answer. 1.13. What is the ratio of the Debt in Euros(%) in Egypt, Arab Rep. in 2007 to that in 2008?
Provide a succinct answer. 1.03. What is the ratio of the Debt in Euros(%) in Pakistan in 2007 to that in 2008?
Your answer should be very brief. 1.16. What is the difference between the highest and the second highest Debt in Euros(%) in Lower middle income?
Your answer should be compact. 0.99. What is the difference between the highest and the second highest Debt in Euros(%) in Egypt, Arab Rep.?
Offer a very short reply. 0.33. What is the difference between the highest and the second highest Debt in Euros(%) in Pakistan?
Offer a terse response. 0.91. What is the difference between the highest and the lowest Debt in Euros(%) of Lower middle income?
Provide a short and direct response. 6.36. What is the difference between the highest and the lowest Debt in Euros(%) of Egypt, Arab Rep.?
Offer a very short reply. 7.72. What is the difference between the highest and the lowest Debt in Euros(%) of Pakistan?
Keep it short and to the point. 3.52. 